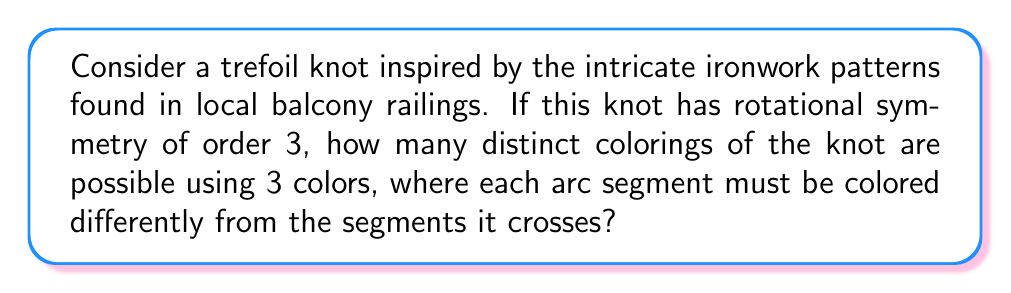Provide a solution to this math problem. Let's approach this step-by-step:

1) First, we need to understand the structure of a trefoil knot. It has three crossings and three arc segments.

2) The rotational symmetry of order 3 means that the knot looks the same after a 120° rotation.

3) In knot theory, we use the Fox n-coloring theorem. For a knot with n crossings, we can use the formula:

   $$\text{Number of colorings} = 3 \cdot (\text{number of solutions to } A\mathbf{x} = \mathbf{0} \pmod{3})$$

   Where A is the coloring matrix of the knot.

4) For a trefoil knot, the coloring matrix is:

   $$A = \begin{pmatrix}
   2 & -1 & -1 \\
   -1 & 2 & -1 \\
   -1 & -1 & 2
   \end{pmatrix}$$

5) We need to solve $A\mathbf{x} = \mathbf{0} \pmod{3}$. Due to the symmetry, all solutions will be of the form $(a,a,a)$ where $a \in \{0,1,2\}$.

6) Substituting into the equation:

   $$(2a-a-a, -a+2a-a, -a-a+2a) = (0,0,0) \pmod{3}$$

7) This is always true for any value of $a$. Therefore, there are 3 solutions: $(0,0,0)$, $(1,1,1)$, and $(2,2,2)$.

8) Applying the formula:

   $$\text{Number of colorings} = 3 \cdot 3 = 9$$

Thus, there are 9 distinct colorings possible.
Answer: 9 